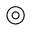Convert formula to latex. <formula><loc_0><loc_0><loc_500><loc_500>\circledcirc</formula> 